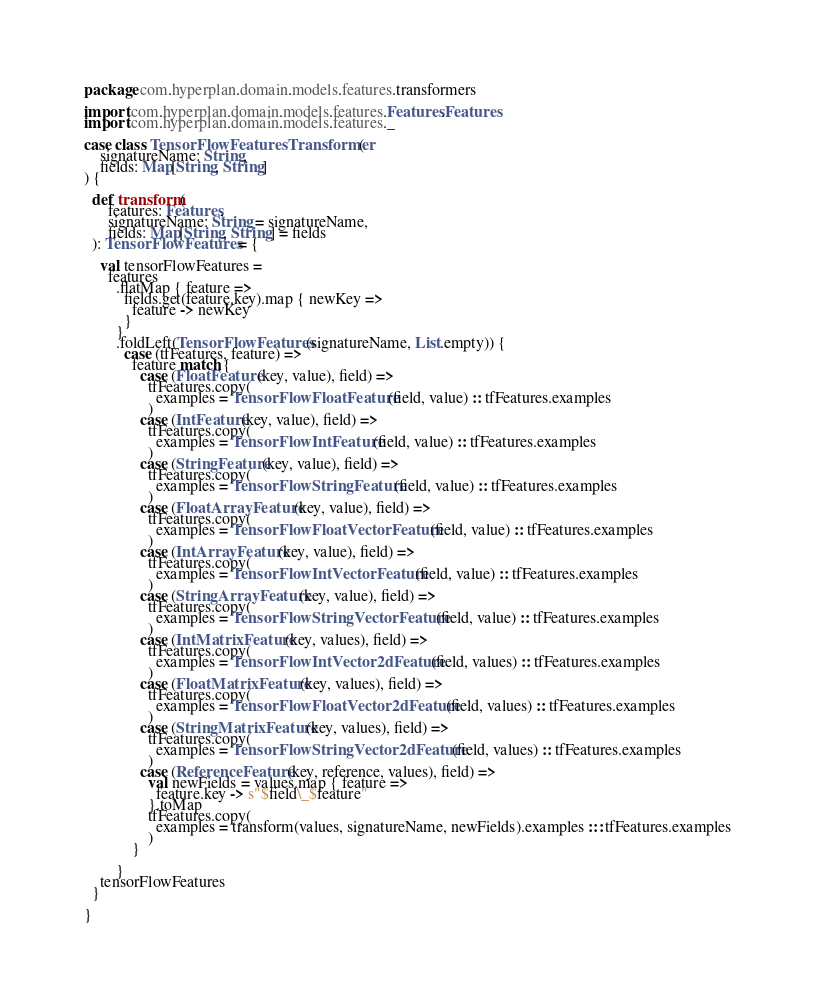<code> <loc_0><loc_0><loc_500><loc_500><_Scala_>package com.hyperplan.domain.models.features.transformers

import com.hyperplan.domain.models.features.Features.Features
import com.hyperplan.domain.models.features._

case class TensorFlowFeaturesTransformer(
    signatureName: String,
    fields: Map[String, String]
) {

  def transform(
      features: Features,
      signatureName: String = signatureName,
      fields: Map[String, String] = fields
  ): TensorFlowFeatures = {

    val tensorFlowFeatures =
      features
        .flatMap { feature =>
          fields.get(feature.key).map { newKey =>
            feature -> newKey
          }
        }
        .foldLeft(TensorFlowFeatures(signatureName, List.empty)) {
          case (tfFeatures, feature) =>
            feature match {
              case (FloatFeature(key, value), field) =>
                tfFeatures.copy(
                  examples = TensorFlowFloatFeature(field, value) :: tfFeatures.examples
                )
              case (IntFeature(key, value), field) =>
                tfFeatures.copy(
                  examples = TensorFlowIntFeature(field, value) :: tfFeatures.examples
                )
              case (StringFeature(key, value), field) =>
                tfFeatures.copy(
                  examples = TensorFlowStringFeature(field, value) :: tfFeatures.examples
                )
              case (FloatArrayFeature(key, value), field) =>
                tfFeatures.copy(
                  examples = TensorFlowFloatVectorFeature(field, value) :: tfFeatures.examples
                )
              case (IntArrayFeature(key, value), field) =>
                tfFeatures.copy(
                  examples = TensorFlowIntVectorFeature(field, value) :: tfFeatures.examples
                )
              case (StringArrayFeature(key, value), field) =>
                tfFeatures.copy(
                  examples = TensorFlowStringVectorFeature(field, value) :: tfFeatures.examples
                )
              case (IntMatrixFeature(key, values), field) =>
                tfFeatures.copy(
                  examples = TensorFlowIntVector2dFeature(field, values) :: tfFeatures.examples
                )
              case (FloatMatrixFeature(key, values), field) =>
                tfFeatures.copy(
                  examples = TensorFlowFloatVector2dFeature(field, values) :: tfFeatures.examples
                )
              case (StringMatrixFeature(key, values), field) =>
                tfFeatures.copy(
                  examples = TensorFlowStringVector2dFeature(field, values) :: tfFeatures.examples
                )
              case (ReferenceFeature(key, reference, values), field) =>
                val newFields = values.map { feature =>
                  feature.key -> s"$field\_$feature"
                }.toMap
                tfFeatures.copy(
                  examples = transform(values, signatureName, newFields).examples ::: tfFeatures.examples
                )
            }

        }
    tensorFlowFeatures
  }

}
</code> 